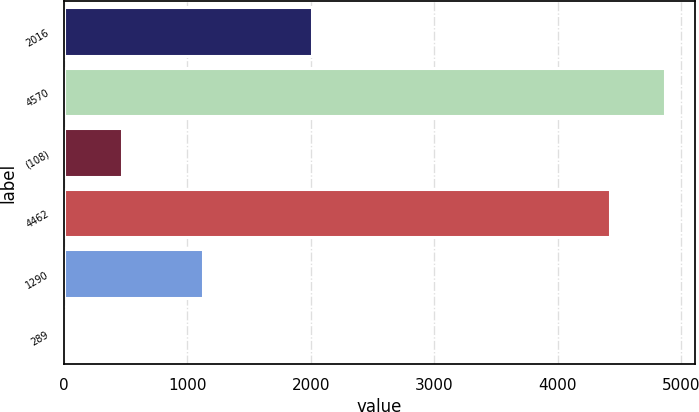Convert chart. <chart><loc_0><loc_0><loc_500><loc_500><bar_chart><fcel>2016<fcel>4570<fcel>(108)<fcel>4462<fcel>1290<fcel>289<nl><fcel>2014<fcel>4869.84<fcel>470.44<fcel>4425<fcel>1131<fcel>25.6<nl></chart> 